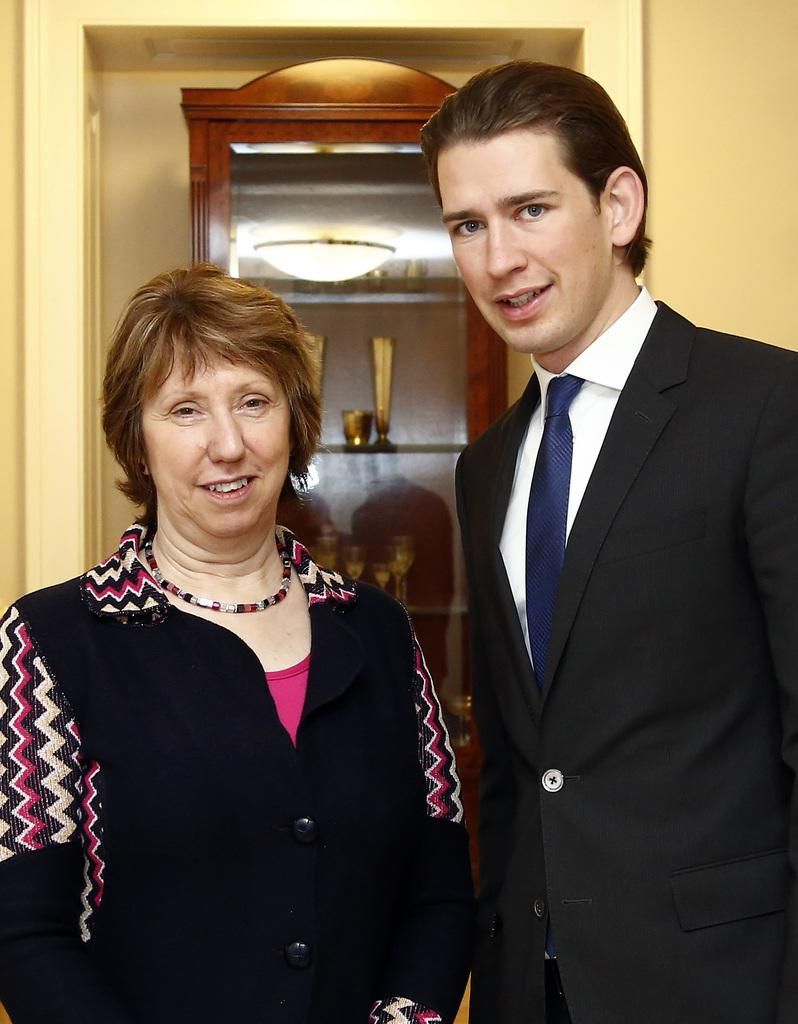How many people are present in the image? There are two people standing in the image. What can be seen in the background of the image? There are glasses and objects in a cupboard in the background. Can you describe the mirror in the image? There is a mirror with a reflection of light in the image. What type of cheese is being used to create the arch in the image? There is no cheese or arch present in the image. Can you describe the donkey in the image? There is no donkey present in the image. 